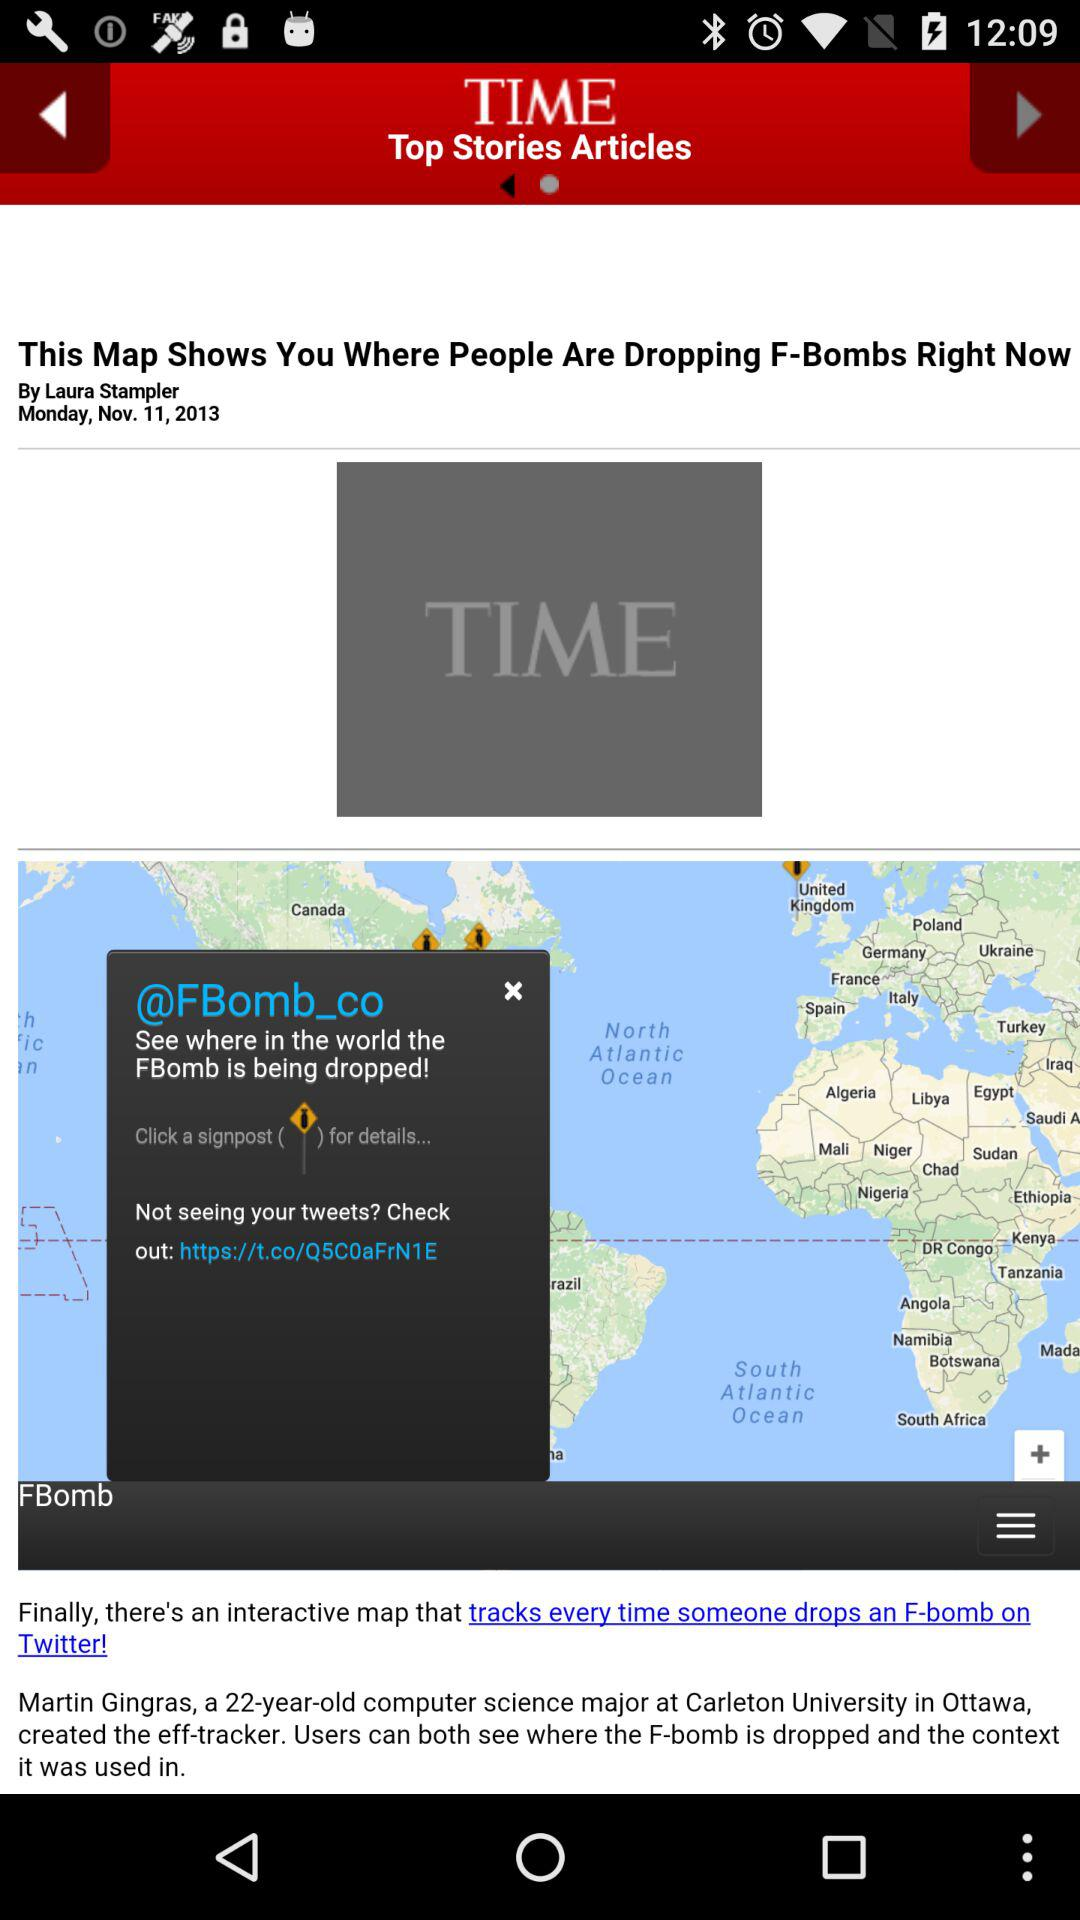What is the magazine's name? The magazine's name is "TIME". 